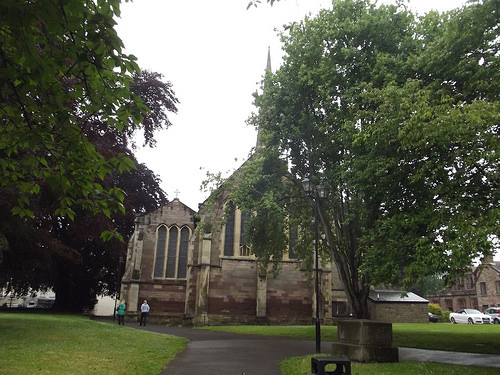<image>
Is there a tree behind the church? No. The tree is not behind the church. From this viewpoint, the tree appears to be positioned elsewhere in the scene. 